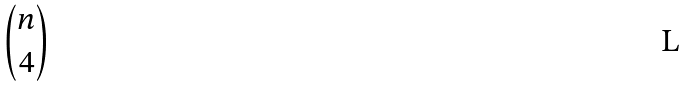<formula> <loc_0><loc_0><loc_500><loc_500>\binom { n } { 4 }</formula> 